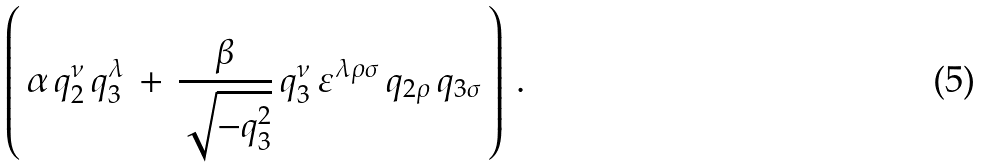<formula> <loc_0><loc_0><loc_500><loc_500>\left ( \, \alpha \, q _ { 2 } ^ { \nu } \, q _ { 3 } ^ { \lambda } \, + \, \frac { \beta } { \sqrt { - q _ { 3 } ^ { 2 } } } \, q _ { 3 } ^ { \nu } \, \varepsilon ^ { \lambda \rho \sigma } \, q _ { 2 \rho } \, q _ { 3 \sigma } \, \right ) \, { . }</formula> 